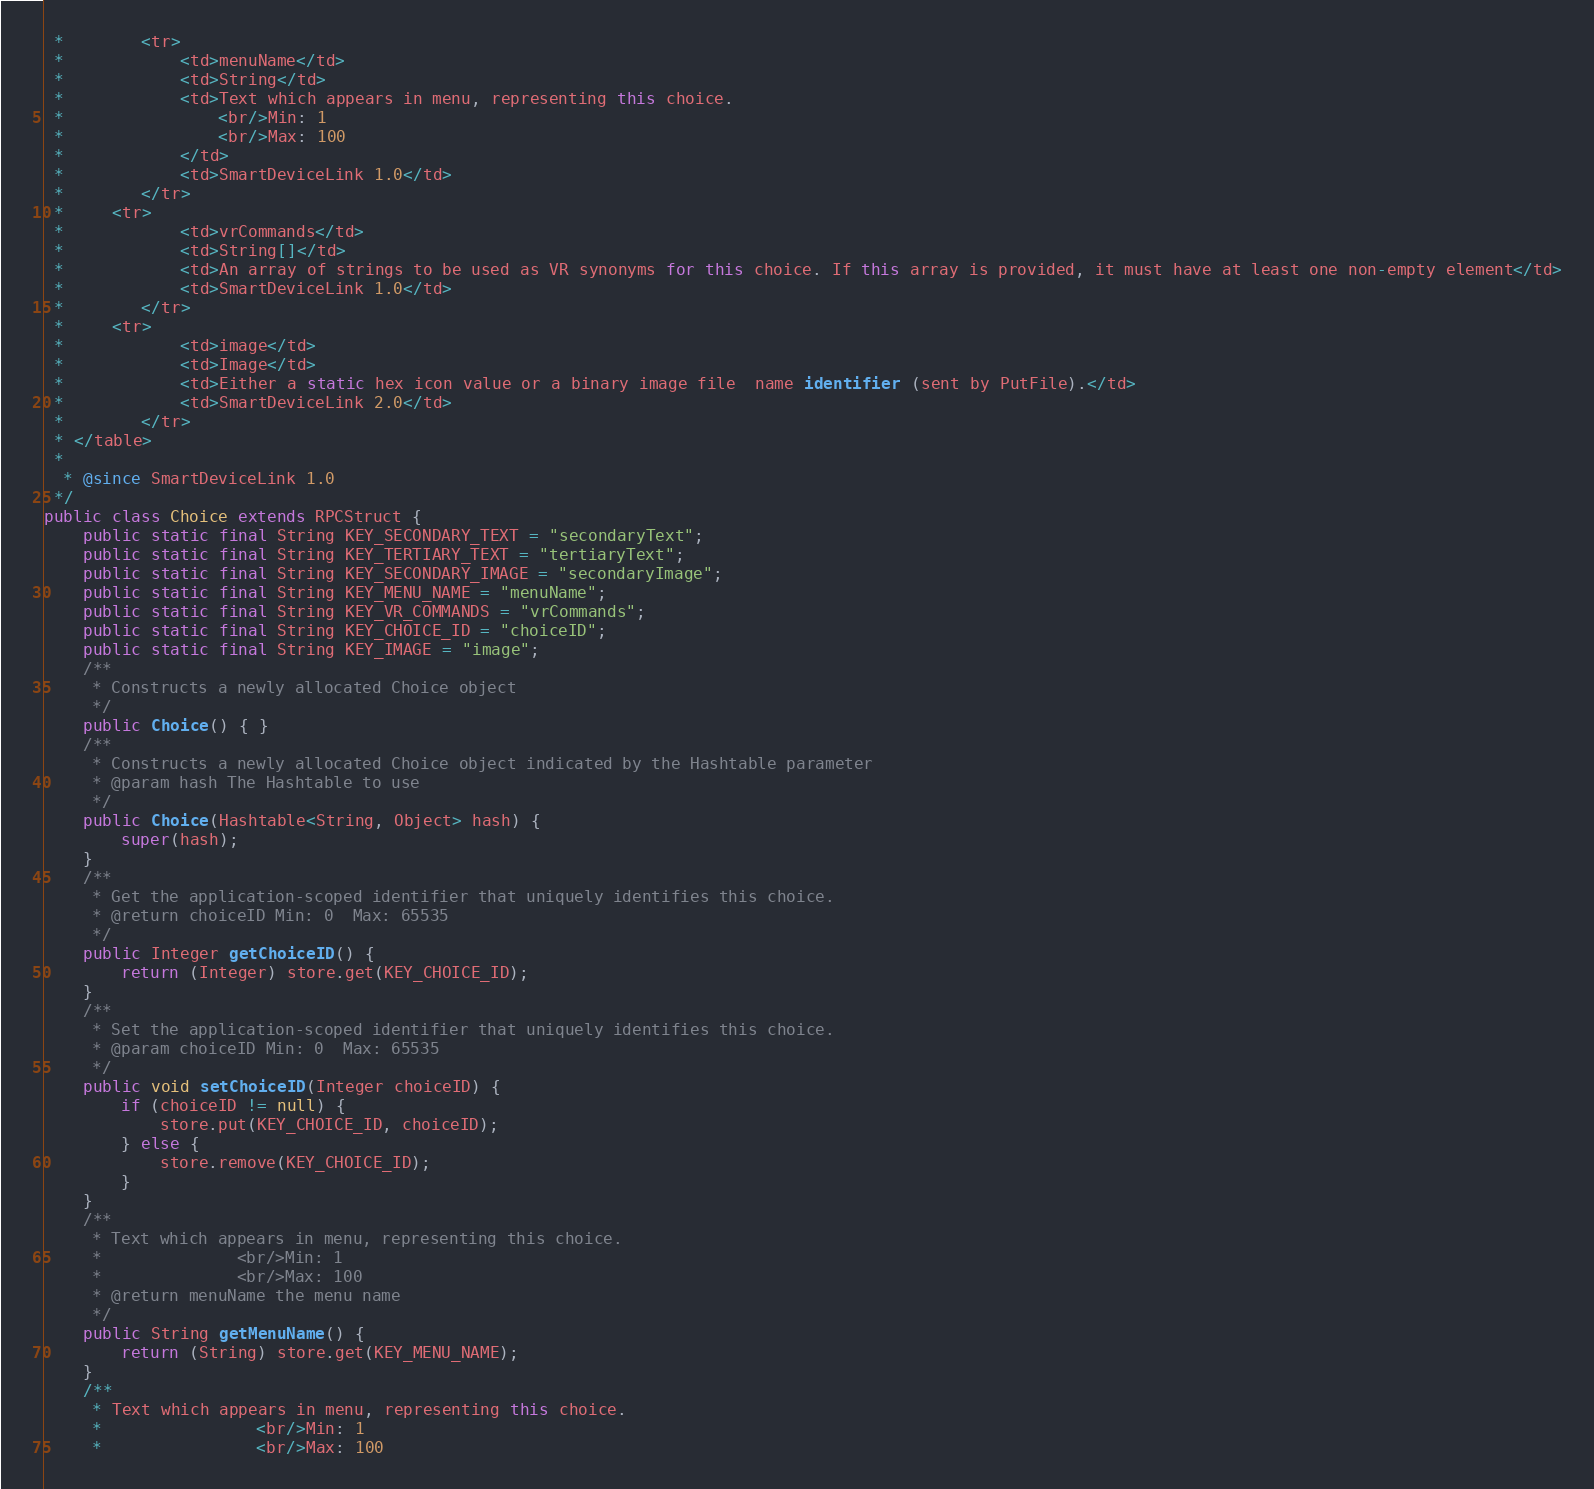<code> <loc_0><loc_0><loc_500><loc_500><_Java_> * 		<tr>
 * 			<td>menuName</td>
 * 			<td>String</td>
 * 			<td>Text which appears in menu, representing this choice.
 *				<br/>Min: 1
 *				<br/>Max: 100
 * 			</td>
 * 			<td>SmartDeviceLink 1.0</td>
 * 		</tr>
 *     <tr>
 * 			<td>vrCommands</td>
 * 			<td>String[]</td>
 * 			<td>An array of strings to be used as VR synonyms for this choice. If this array is provided, it must have at least one non-empty element</td>
 * 			<td>SmartDeviceLink 1.0</td>
 * 		</tr>
 *     <tr>
 * 			<td>image</td>
 * 			<td>Image</td>
 * 			<td>Either a static hex icon value or a binary image file  name identifier (sent by PutFile).</td>
 * 			<td>SmartDeviceLink 2.0</td>
 * 		</tr>
 * </table>
 * 
  * @since SmartDeviceLink 1.0
 */
public class Choice extends RPCStruct {
	public static final String KEY_SECONDARY_TEXT = "secondaryText";
	public static final String KEY_TERTIARY_TEXT = "tertiaryText";
	public static final String KEY_SECONDARY_IMAGE = "secondaryImage";
	public static final String KEY_MENU_NAME = "menuName";
	public static final String KEY_VR_COMMANDS = "vrCommands";
	public static final String KEY_CHOICE_ID = "choiceID";
	public static final String KEY_IMAGE = "image";
	/**
	 * Constructs a newly allocated Choice object
	 */
    public Choice() { }
    /**
     * Constructs a newly allocated Choice object indicated by the Hashtable parameter
     * @param hash The Hashtable to use
     */    
    public Choice(Hashtable<String, Object> hash) {
        super(hash);
    }
    /**
     * Get the application-scoped identifier that uniquely identifies this choice.
     * @return choiceID Min: 0  Max: 65535
     */    
    public Integer getChoiceID() {
        return (Integer) store.get(KEY_CHOICE_ID);
    }
    /**
     * Set the application-scoped identifier that uniquely identifies this choice.
     * @param choiceID Min: 0  Max: 65535
     */    
    public void setChoiceID(Integer choiceID) {
        if (choiceID != null) {
            store.put(KEY_CHOICE_ID, choiceID);
        } else {
        	store.remove(KEY_CHOICE_ID);
        }
    }
    /**
     * Text which appears in menu, representing this choice.
     *				<br/>Min: 1
     *				<br/>Max: 100
     * @return menuName the menu name
     */    
    public String getMenuName() {
        return (String) store.get(KEY_MENU_NAME);
    }
    /**
     * Text which appears in menu, representing this choice.
     *				<br/>Min: 1
     *				<br/>Max: 100</code> 